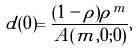Convert formula to latex. <formula><loc_0><loc_0><loc_500><loc_500>d ( 0 ) = \frac { ( 1 - \rho ) \rho ^ { m } } { A ( m , 0 ; 0 ) } ,</formula> 